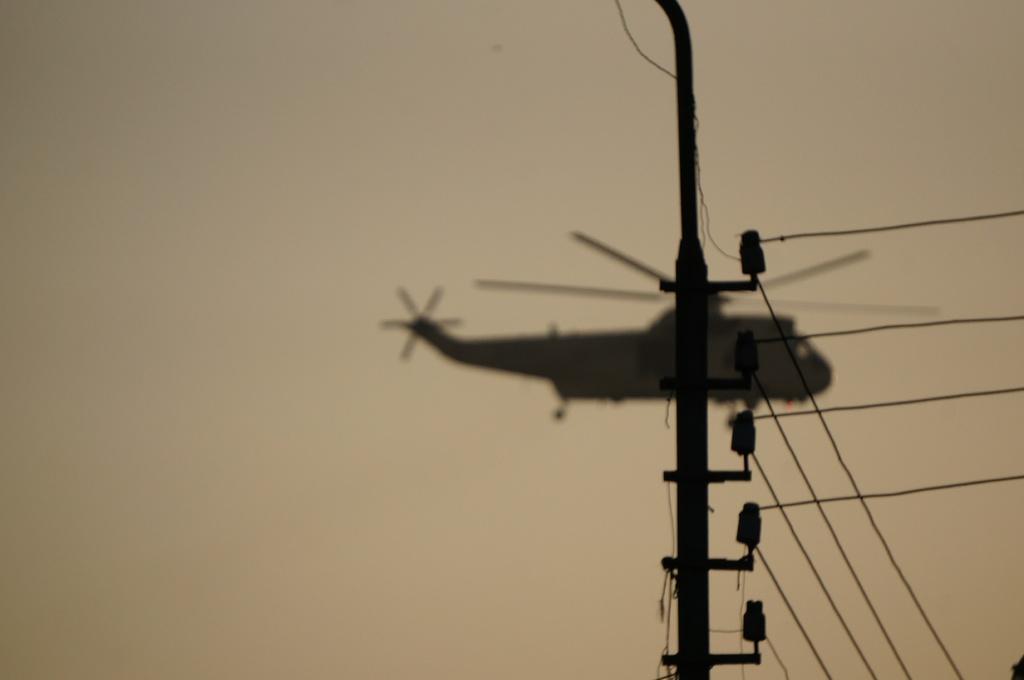Can you describe this image briefly? In this picture we can see a pole, wires, some objects and in the background we can see a helicopter flying in the sky. 